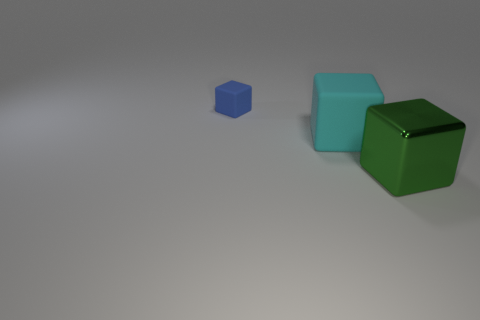How many objects are either large matte things or large blocks to the left of the shiny block?
Keep it short and to the point. 1. There is a matte block that is to the right of the cube that is left of the big cyan object; what is its size?
Your answer should be compact. Large. Is the number of large cyan matte cubes in front of the large cyan thing the same as the number of cyan objects that are behind the blue matte block?
Provide a short and direct response. Yes. Are there any large rubber things behind the matte block in front of the small blue matte cube?
Provide a succinct answer. No. Are there any other things of the same color as the large rubber block?
Keep it short and to the point. No. What is the material of the block behind the big cube to the left of the green shiny block?
Your answer should be very brief. Rubber. Is there a yellow shiny thing that has the same shape as the green metal object?
Make the answer very short. No. How many other things are the same shape as the small matte object?
Give a very brief answer. 2. What is the shape of the object that is in front of the small blue block and behind the big metal block?
Offer a very short reply. Cube. There is a object that is in front of the large matte cube; what is its size?
Ensure brevity in your answer.  Large. 